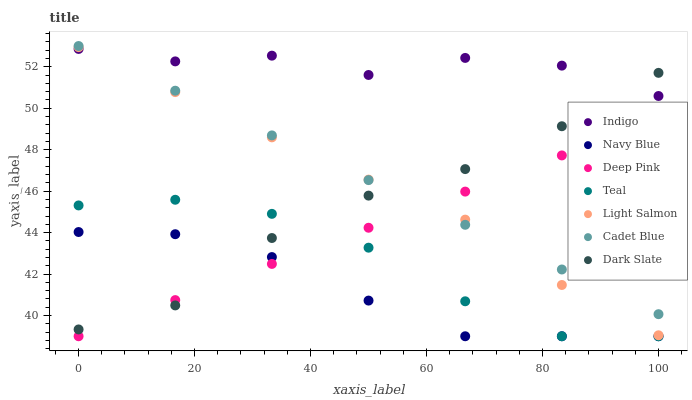Does Navy Blue have the minimum area under the curve?
Answer yes or no. Yes. Does Indigo have the maximum area under the curve?
Answer yes or no. Yes. Does Cadet Blue have the minimum area under the curve?
Answer yes or no. No. Does Cadet Blue have the maximum area under the curve?
Answer yes or no. No. Is Deep Pink the smoothest?
Answer yes or no. Yes. Is Indigo the roughest?
Answer yes or no. Yes. Is Cadet Blue the smoothest?
Answer yes or no. No. Is Cadet Blue the roughest?
Answer yes or no. No. Does Navy Blue have the lowest value?
Answer yes or no. Yes. Does Cadet Blue have the lowest value?
Answer yes or no. No. Does Cadet Blue have the highest value?
Answer yes or no. Yes. Does Indigo have the highest value?
Answer yes or no. No. Is Teal less than Indigo?
Answer yes or no. Yes. Is Indigo greater than Deep Pink?
Answer yes or no. Yes. Does Teal intersect Dark Slate?
Answer yes or no. Yes. Is Teal less than Dark Slate?
Answer yes or no. No. Is Teal greater than Dark Slate?
Answer yes or no. No. Does Teal intersect Indigo?
Answer yes or no. No. 